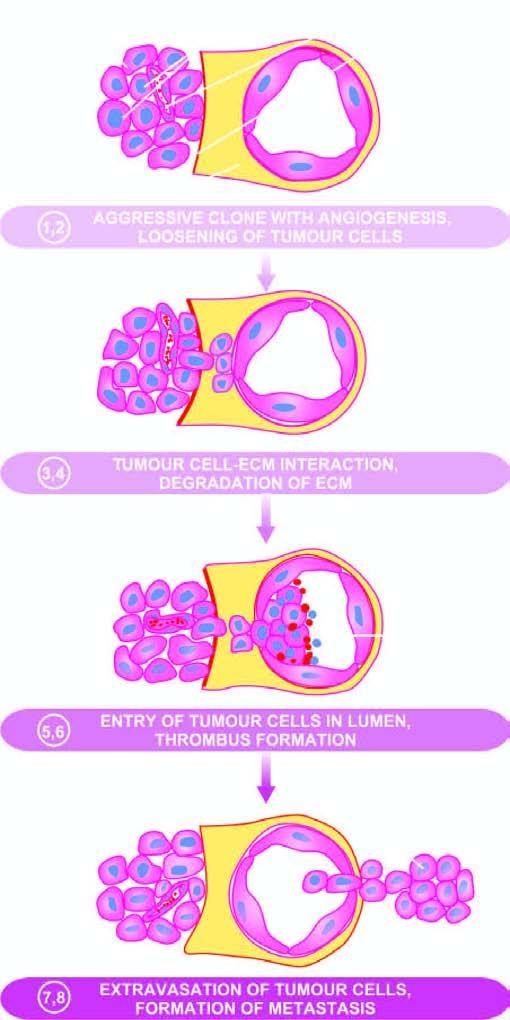do the serial numbers in the figure correspond to their description in the text?
Answer the question using a single word or phrase. Yes 